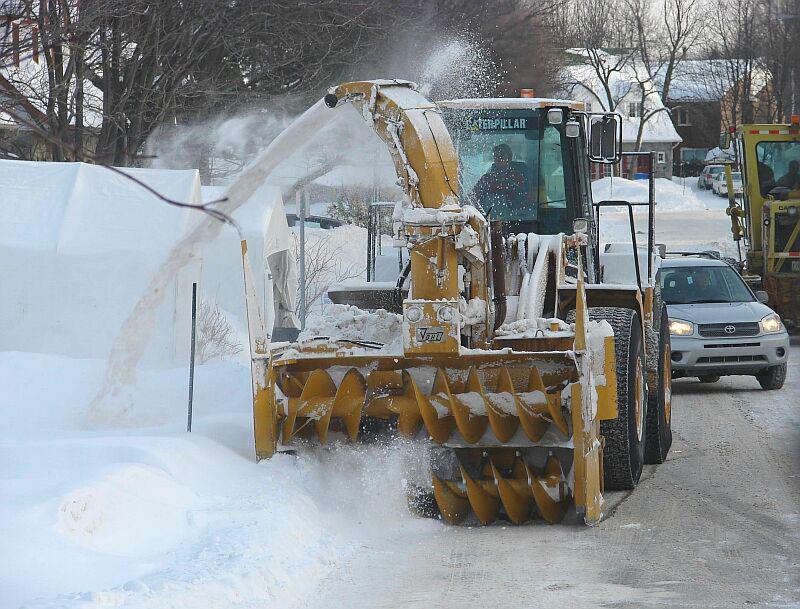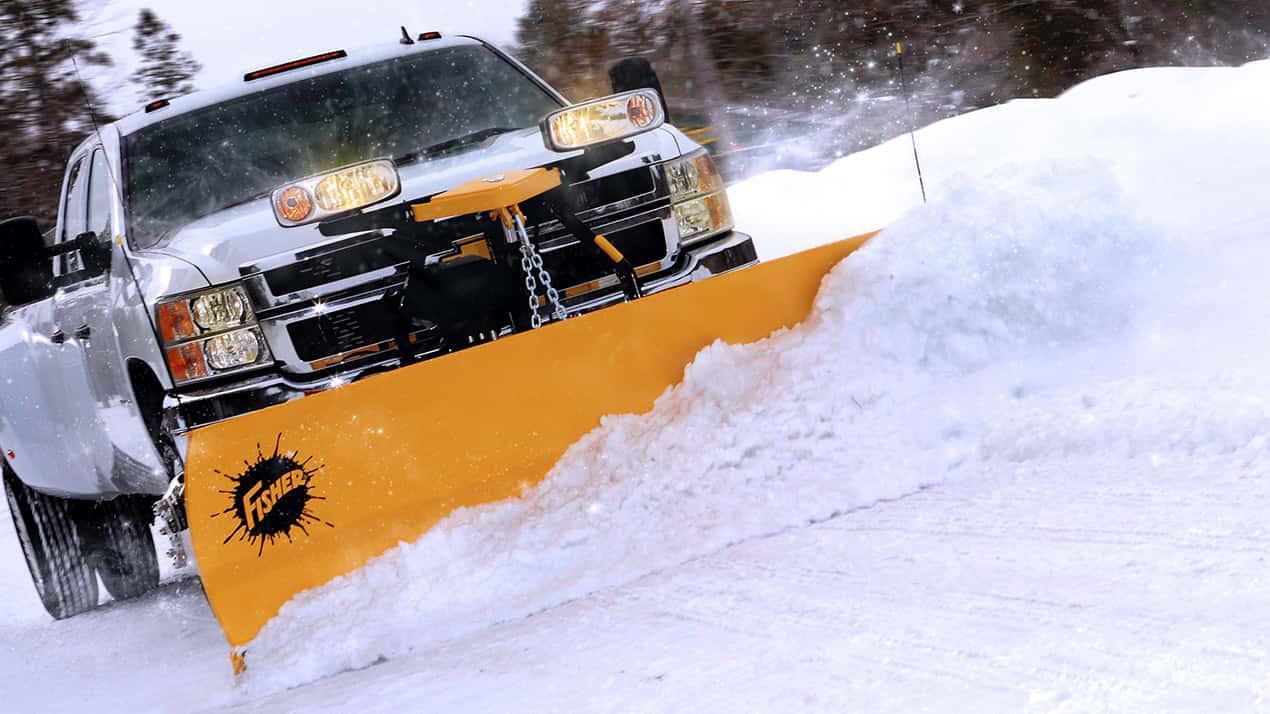The first image is the image on the left, the second image is the image on the right. Given the left and right images, does the statement "There are two pick up trucks with a solid colored snow plow attached plowing snow." hold true? Answer yes or no. No. 